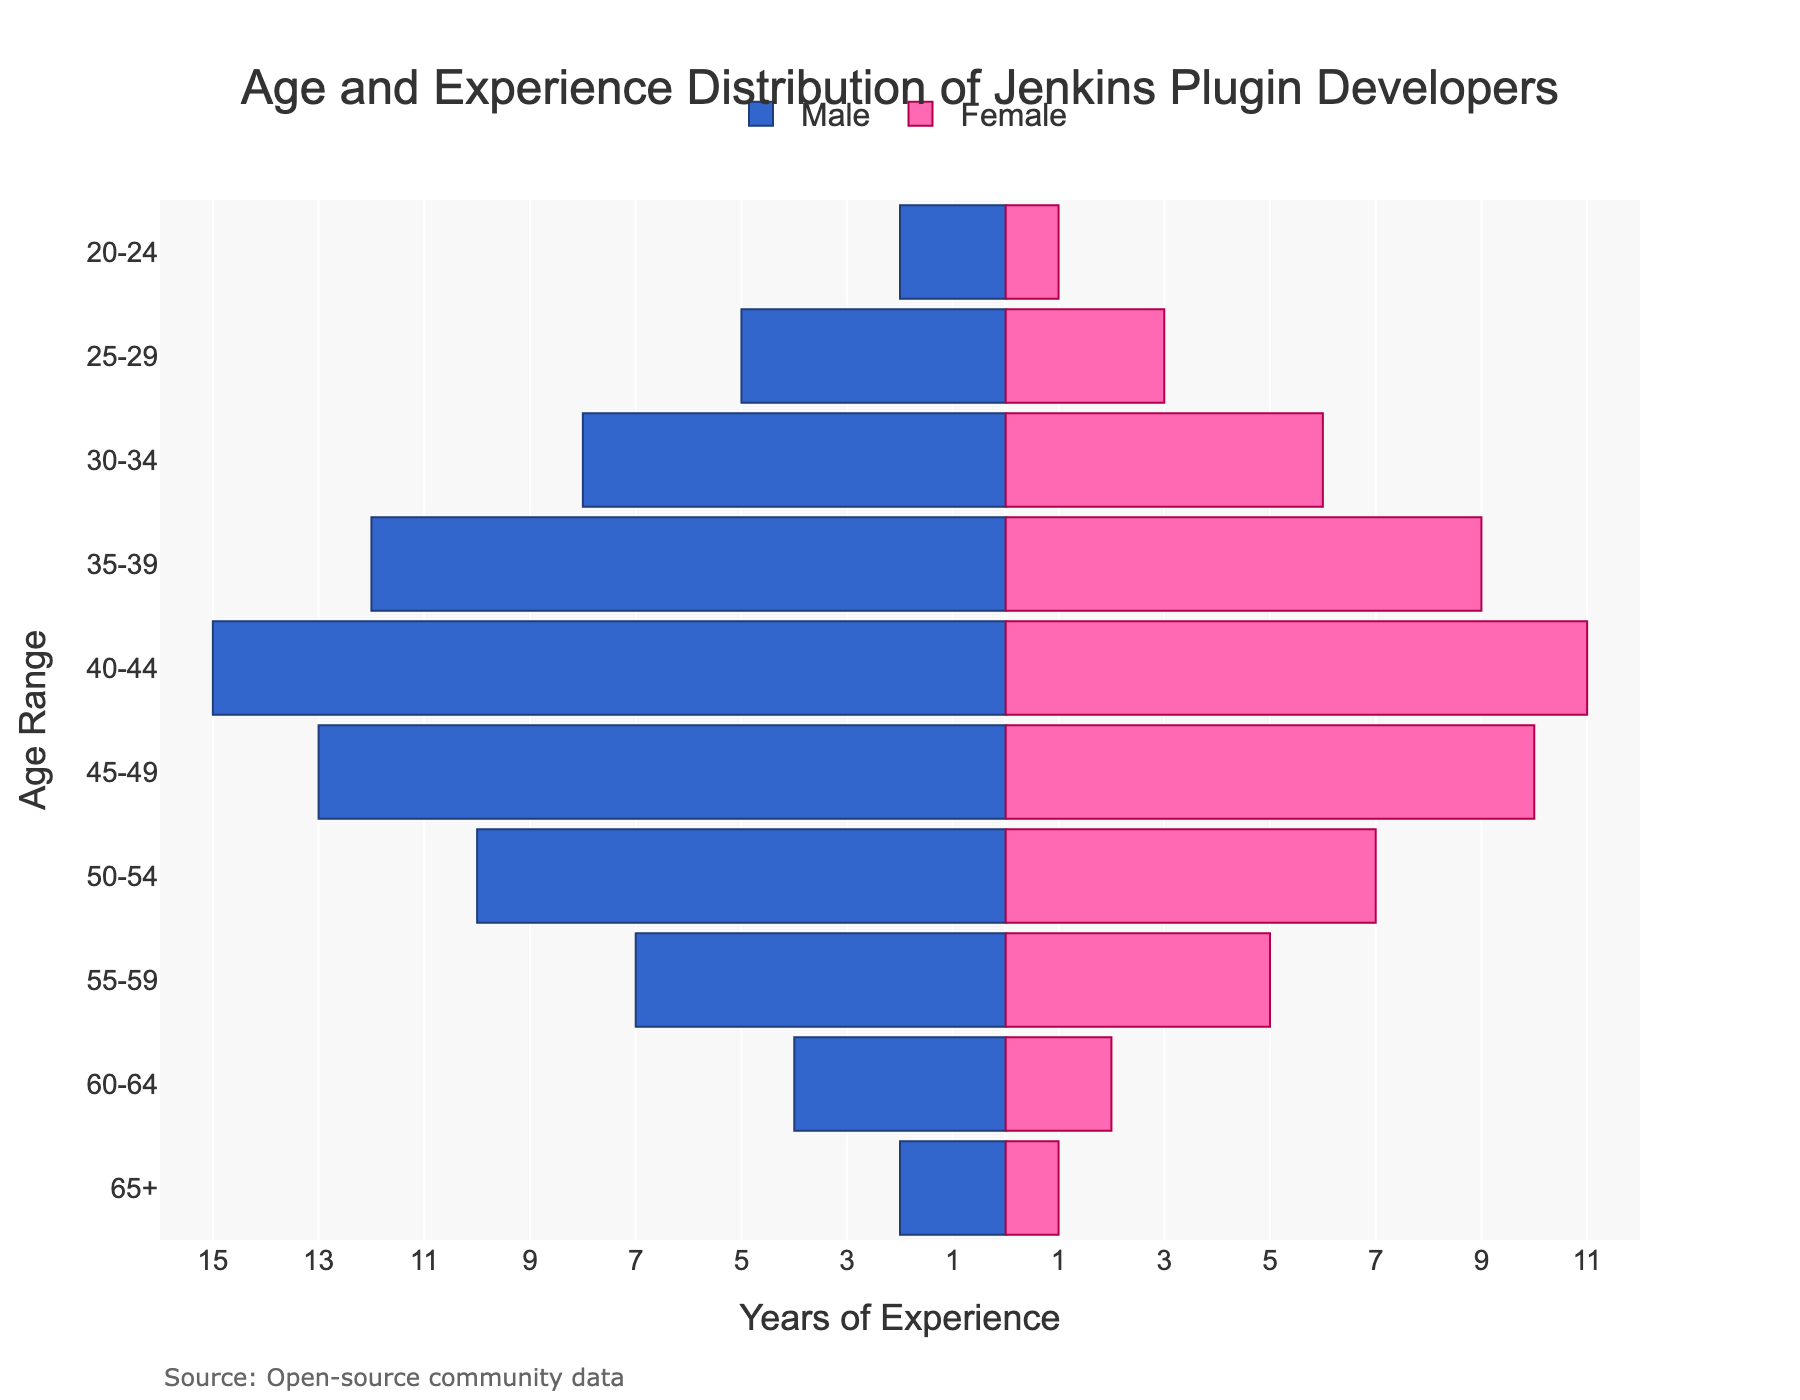What's the age range with the highest years of male experience? We look at the bar lengths for males in each age category and find that the age range 40-44 has the longest bar.
Answer: 40-44 Which age range shows the least experience for both males and females? We identify the smallest bar lengths for both male and female categories and find they are in the 20-24 age range.
Answer: 20-24 What's the total experience for females in the 35-39 age range? We look at the bar length for females in the 35-39 age range, which is 9 years.
Answer: 9 years How much more experience do males aged 50-54 have compared to females in the same age range? The experience for males aged 50-54 is 10 years, while for females, it's 7 years. The difference is 10 - 7 = 3 years.
Answer: 3 years In which age range is the experience most balanced between males and females? We compare the experience values for each age range and find 50-54 has close values: 10 years for males and 7 years for females.
Answer: 50-54 What's the combined experience for both genders in the age range 45-49? We add the male experience (13 years) and female experience (10 years) for the age range 45-49: 13 + 10 = 23 years.
Answer: 23 years Which gender has more experience in the 30-34 age range, and by how much? Male experience is 8 years, female experience is 6 years. Males have more experience by 8 - 6 = 2 years.
Answer: Males, by 2 years Is there any age range where females have more experience than males? We compare all age ranges and notice that males always have equal or more experience compared to females.
Answer: No What's the median years of experience for males across all age ranges? First, we list the male experiences: [2, 5, 8, 12, 15, 13, 10, 7, 4, 2]. After sorting, we get [2, 2, 4, 5, 7, 8, 10, 12, 13, 15]; the median is the average of the 5th and 6th values: (7+8)/2 = 7.5
Answer: 7.5 years What proportion of the total experience does the 40-44 age range account for males? Summing all male experiences: 2+5+8+12+15+13+10+7+4+2 = 78. The 40-44 range has 15 years, so the proportion is 15/78. Simplified, 15/78 ≈ 0.192 or 19.2%.
Answer: 19.2% 